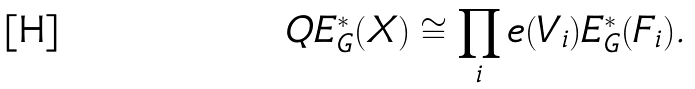Convert formula to latex. <formula><loc_0><loc_0><loc_500><loc_500>Q E ^ { * } _ { G } ( X ) \cong \prod _ { i } e ( V _ { i } ) E ^ { * } _ { G } ( F _ { i } ) .</formula> 